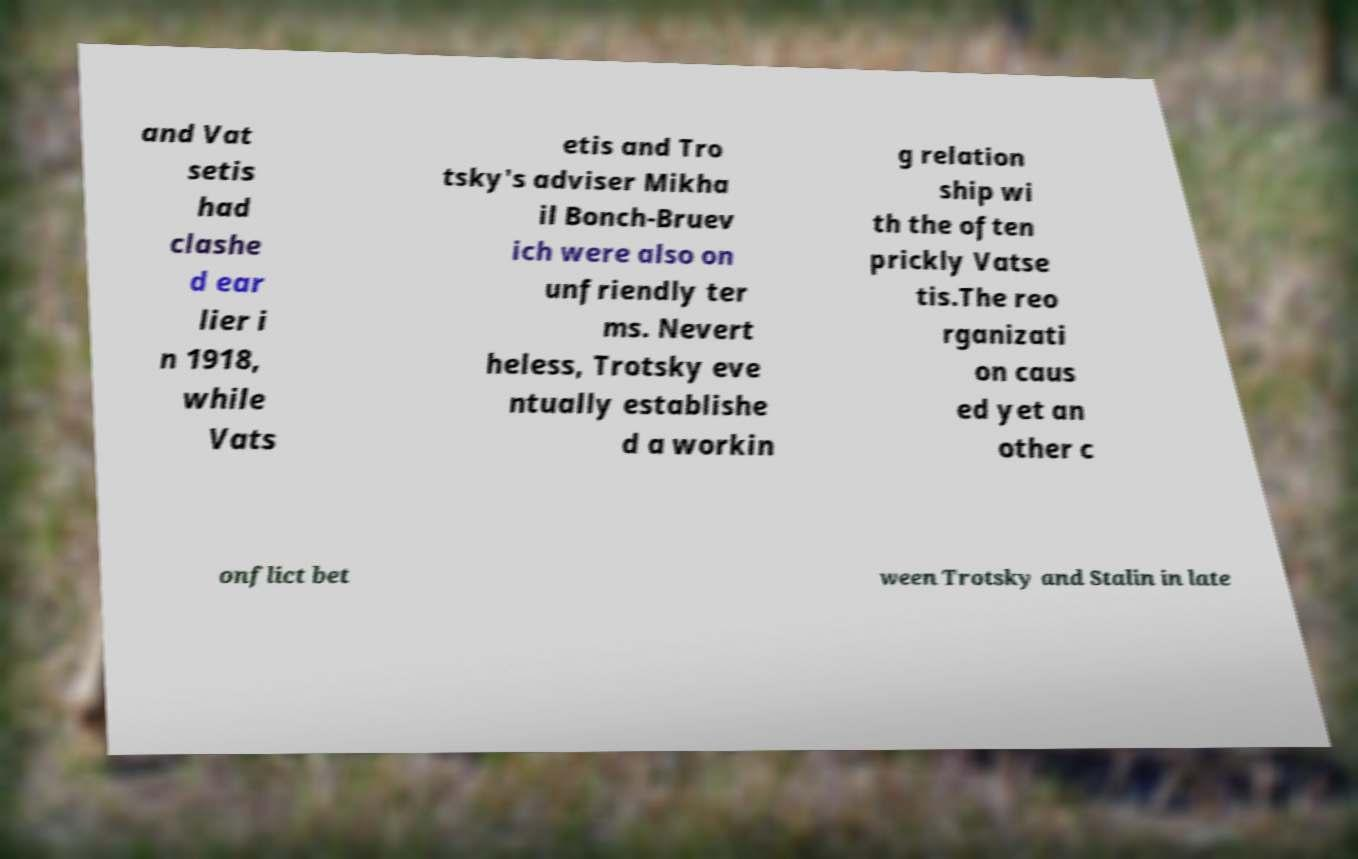Please read and relay the text visible in this image. What does it say? and Vat setis had clashe d ear lier i n 1918, while Vats etis and Tro tsky's adviser Mikha il Bonch-Bruev ich were also on unfriendly ter ms. Nevert heless, Trotsky eve ntually establishe d a workin g relation ship wi th the often prickly Vatse tis.The reo rganizati on caus ed yet an other c onflict bet ween Trotsky and Stalin in late 